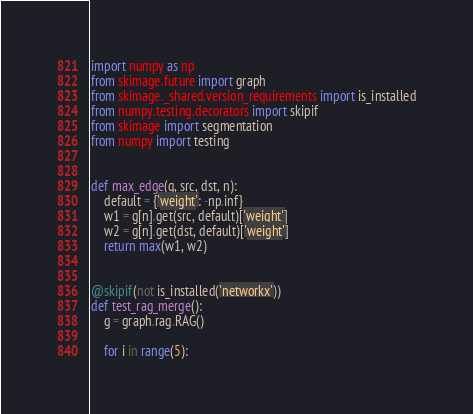Convert code to text. <code><loc_0><loc_0><loc_500><loc_500><_Python_>import numpy as np
from skimage.future import graph
from skimage._shared.version_requirements import is_installed
from numpy.testing.decorators import skipif
from skimage import segmentation
from numpy import testing


def max_edge(g, src, dst, n):
    default = {'weight': -np.inf}
    w1 = g[n].get(src, default)['weight']
    w2 = g[n].get(dst, default)['weight']
    return max(w1, w2)


@skipif(not is_installed('networkx'))
def test_rag_merge():
    g = graph.rag.RAG()

    for i in range(5):</code> 